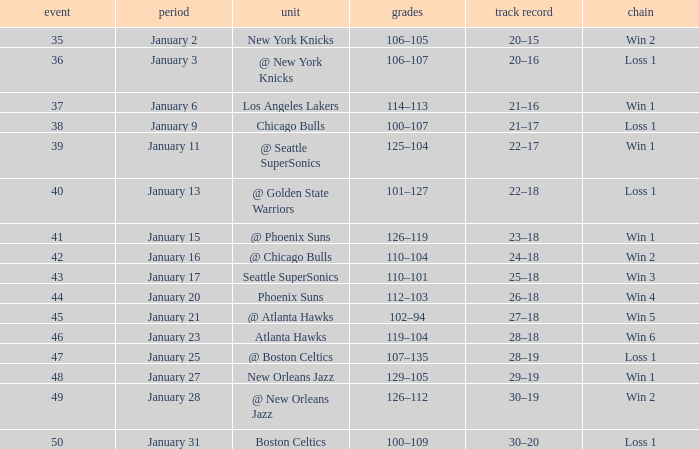What Game had a Score of 129–105? 48.0. 